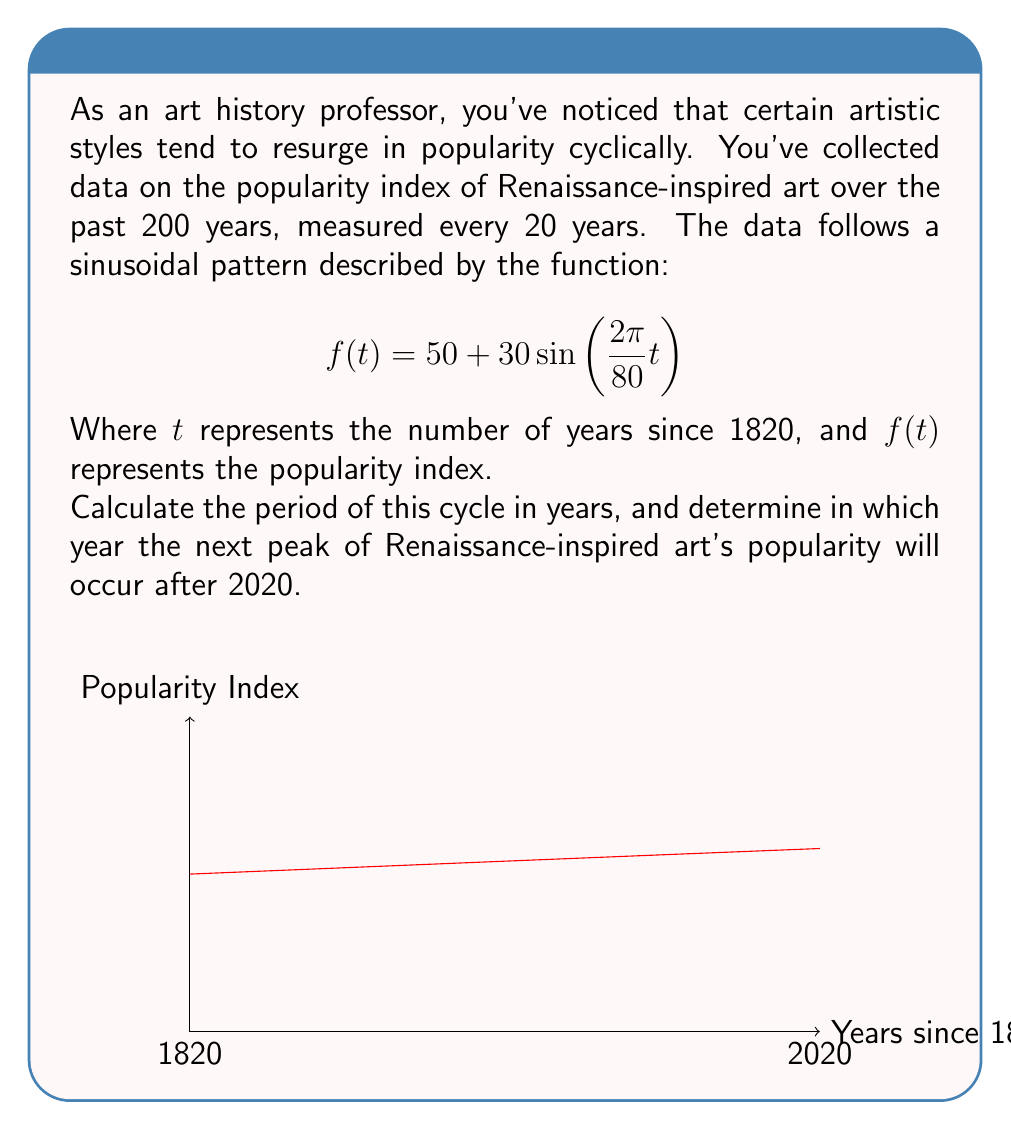Teach me how to tackle this problem. To solve this problem, we'll follow these steps:

1) First, let's identify the period of the sinusoidal function. The general form of a sine function is:

   $$f(t) = A\sin\left(\frac{2\pi}{P}t\right) + B$$

   Where $P$ is the period.

2) In our function, $$f(t) = 50 + 30\sin\left(\frac{2\pi}{80}t\right)$$
   We can see that $\frac{2\pi}{P} = \frac{2\pi}{80}$

3) Solving for $P$:
   $$P = 80$$

   Therefore, the period of the cycle is 80 years.

4) To find the next peak after 2020, we need to:
   a) Determine how many years have passed since 1820 to 2020
   b) Find the next multiple of 80 after this number

5) Years from 1820 to 2020: 2020 - 1820 = 200 years

6) The next multiple of 80 after 200 is 240:
   $$\left\lceil\frac{200}{80}\right\rceil \cdot 80 = 3 \cdot 80 = 240$$

7) Therefore, the next peak will occur 240 years after 1820:
   1820 + 240 = 2060
Answer: Period: 80 years; Next peak: 2060 